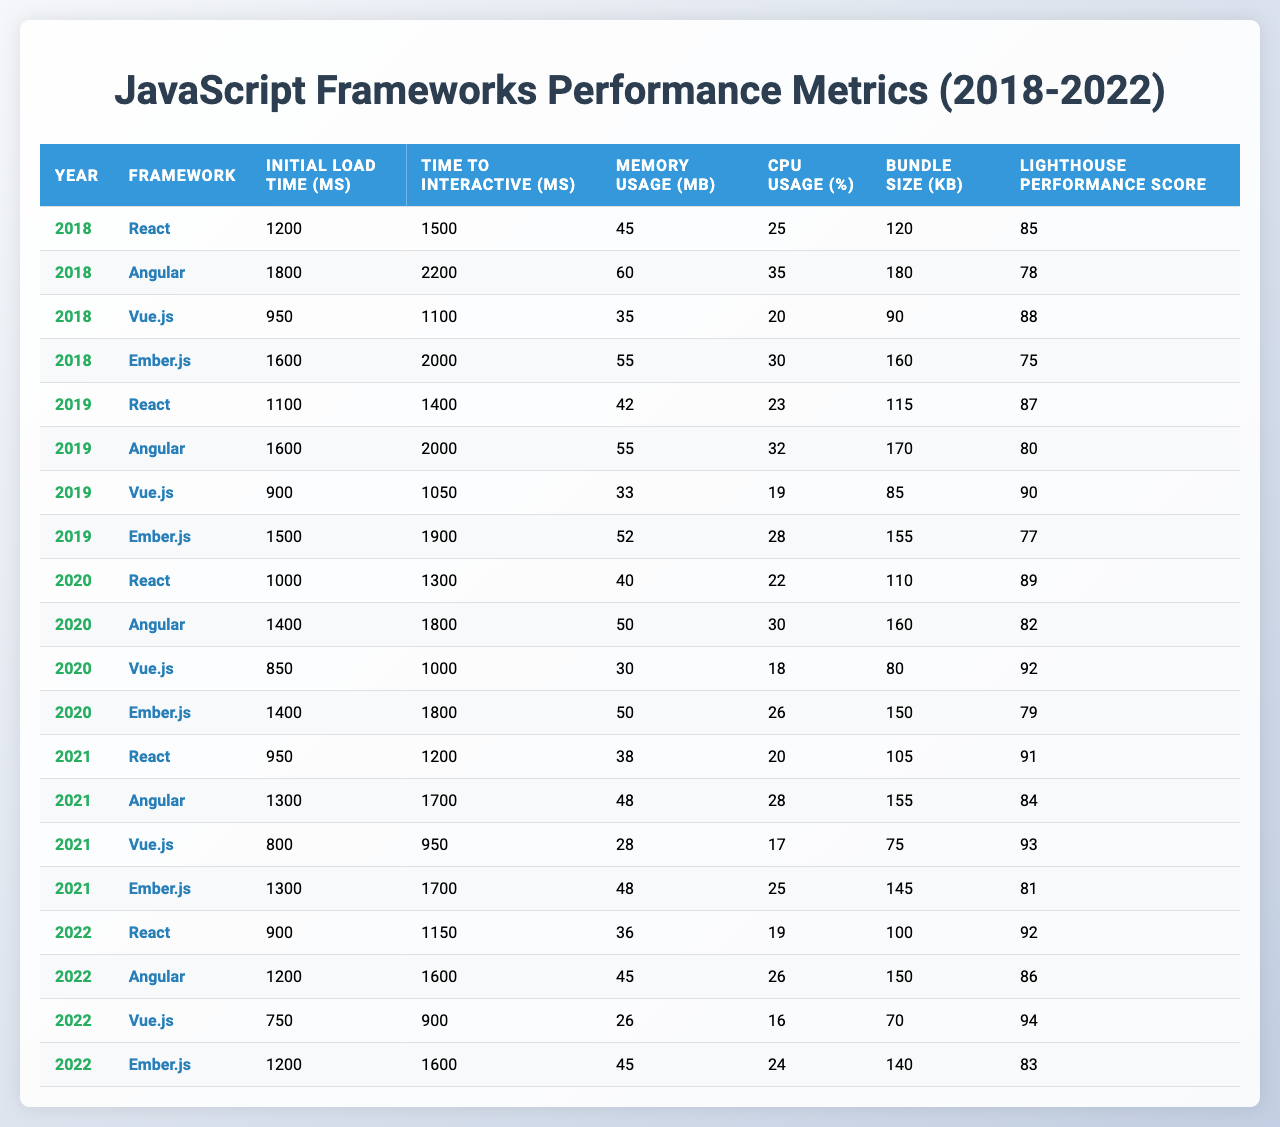What was the Initial Load Time of Vue.js in 2021? In 2021, the Initial Load Time for Vue.js is stated in the table as 800 ms.
Answer: 800 ms Which framework had the lowest Memory Usage in 2019? In 2019, Vue.js showed the lowest Memory Usage of 33 MB compared to other frameworks.
Answer: Vue.js What is the average Time to Interactive across all frameworks in 2020? The values for Time to Interactive in 2020 are 1300, 1800, 1000, and 1800 ms. Adding them together gives 1300 + 1800 + 1000 + 1800 = 5900 ms. Dividing by 4 (the number of frameworks) results in an average of 1475 ms.
Answer: 1475 ms Did Angular's Lighthouse Performance Score improve each year from 2018 to 2022? The Lighthouse Performance Scores for Angular from 2018 to 2022 are 78, 80, 82, 84, and 86, which shows a consistent increase each year.
Answer: Yes Which framework had the highest Bundle Size in 2020, and what was its value? In 2020, Angular had the highest Bundle Size of 160 KB, exceeding other frameworks.
Answer: Angular, 160 KB What was the difference in CPU Usage between React and Ember.js in 2022? React's CPU Usage in 2022 is 19%, while Ember.js is 24%. The difference is 24 - 19 = 5%.
Answer: 5% In which year did Vue.js achieve the best Lighthouse Performance Score? The Lighthouse Performance Score for Vue.js was highest in 2022, reaching 94.
Answer: 2022 What was the overall trend for Initial Load Time from 2018 to 2022 for React? The Initial Load Time for React started at 1200 ms in 2018 and improved to 900 ms by 2022, indicating a downward trend.
Answer: Downward trend Which framework consistently had the highest Initial Load Time over the years shown? The table shows Ember.js had the highest Initial Load Time in 2018 (1600 ms), 2019 (1500 ms), 2020 (1400 ms), 2021 (1300 ms), and 2022 (1200 ms).
Answer: Ember.js What was the change in Bundle Size for Vue.js from 2018 to 2022? Vue.js's Bundle Size decreased from 90 KB in 2018 to 70 KB in 2022, representing a change of 20 KB.
Answer: 20 KB decrease 